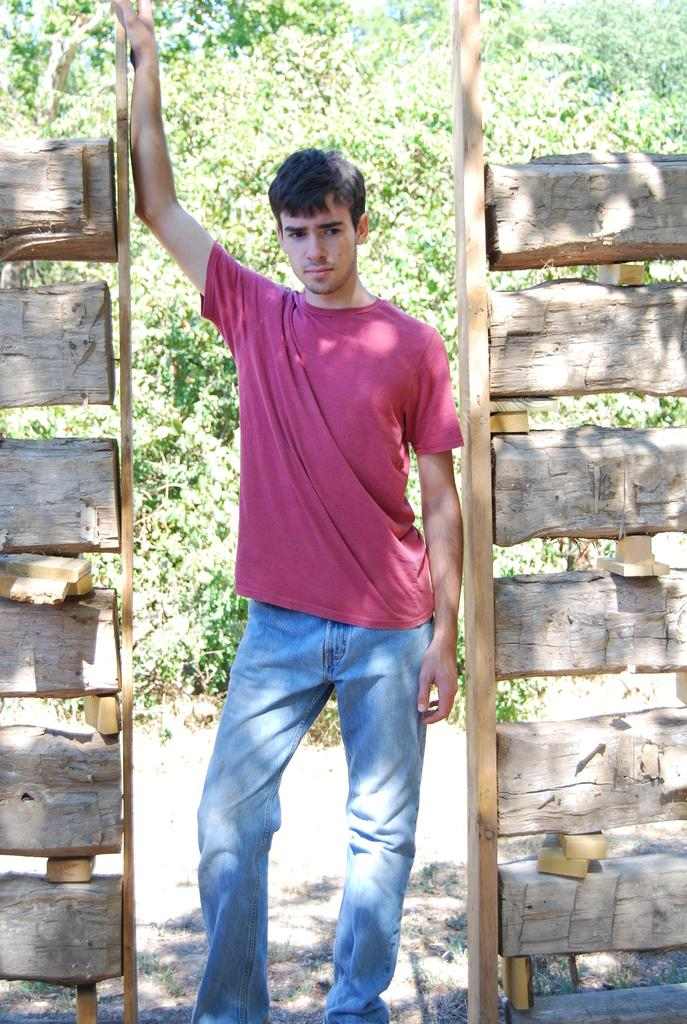What is the main subject of the image? There is a man standing in the image. What is the man wearing on his upper body? The man is wearing a t-shirt. What type of pants is the man wearing? The man is wearing blue jeans. What can be seen in the background of the image? There are trees in the background of the image. Are there any fairies flying around the man in the image? No, there are no fairies present in the image. What type of science experiment is being conducted in the image? There is no science experiment visible in the image; it features a man standing in front of trees. 